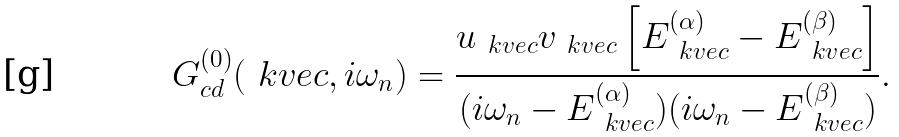Convert formula to latex. <formula><loc_0><loc_0><loc_500><loc_500>G ^ { ( 0 ) } _ { c d } ( \ k v e c , i \omega _ { n } ) = \frac { u _ { \ k v e c } v _ { \ k v e c } \left [ E ^ { ( \alpha ) } _ { \ k v e c } - E ^ { ( \beta ) } _ { \ k v e c } \right ] } { ( i \omega _ { n } - E ^ { ( \alpha ) } _ { \ k v e c } ) ( i \omega _ { n } - E ^ { ( \beta ) } _ { \ k v e c } ) } .</formula> 